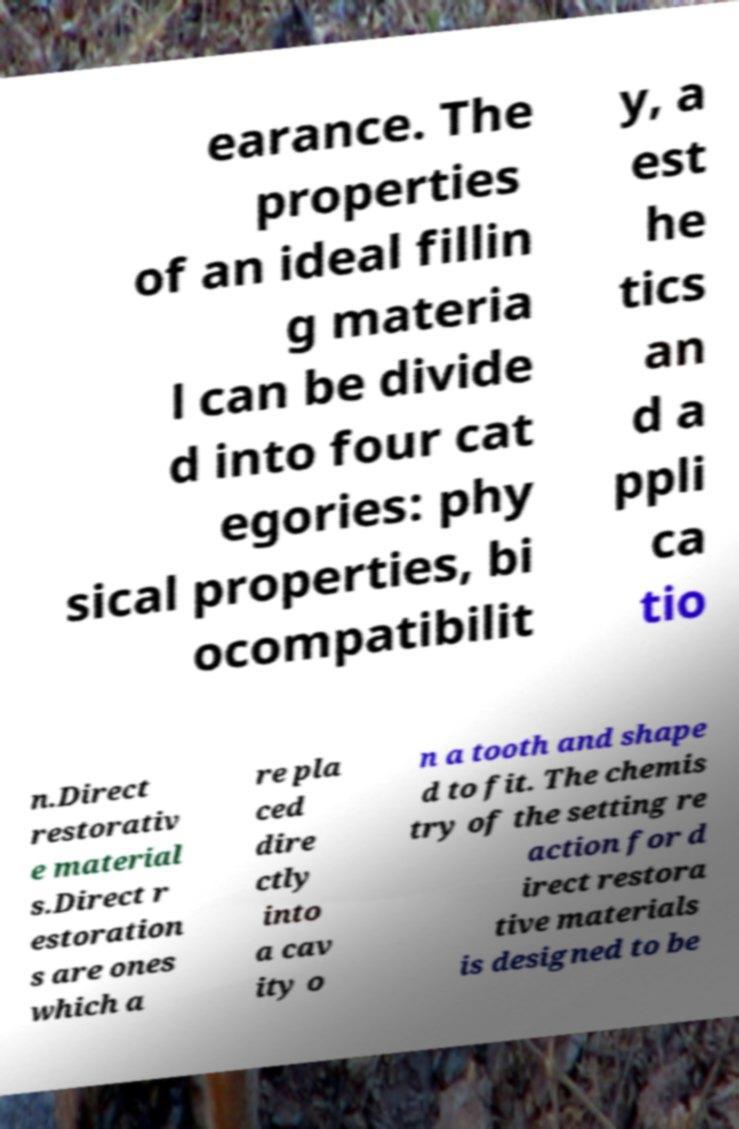What messages or text are displayed in this image? I need them in a readable, typed format. earance. The properties of an ideal fillin g materia l can be divide d into four cat egories: phy sical properties, bi ocompatibilit y, a est he tics an d a ppli ca tio n.Direct restorativ e material s.Direct r estoration s are ones which a re pla ced dire ctly into a cav ity o n a tooth and shape d to fit. The chemis try of the setting re action for d irect restora tive materials is designed to be 